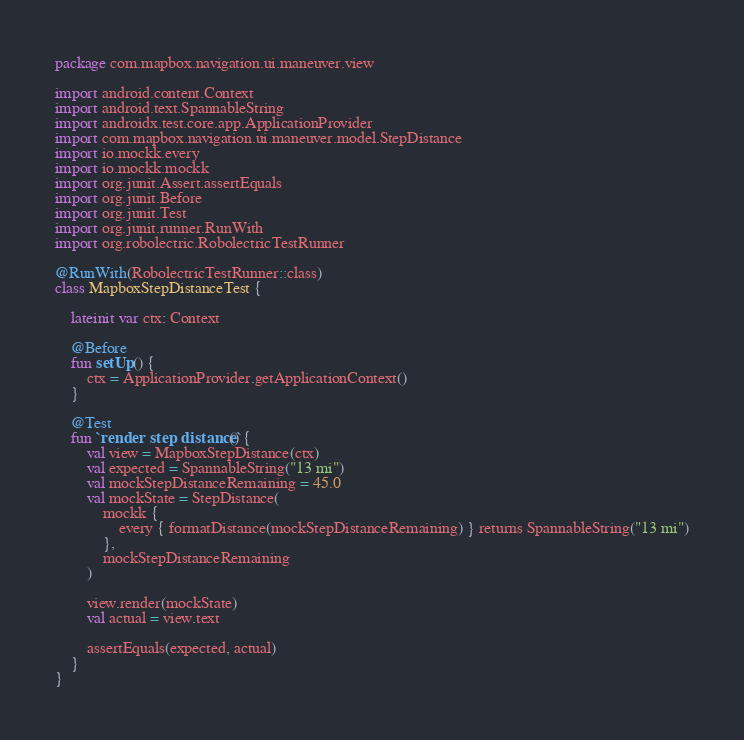Convert code to text. <code><loc_0><loc_0><loc_500><loc_500><_Kotlin_>package com.mapbox.navigation.ui.maneuver.view

import android.content.Context
import android.text.SpannableString
import androidx.test.core.app.ApplicationProvider
import com.mapbox.navigation.ui.maneuver.model.StepDistance
import io.mockk.every
import io.mockk.mockk
import org.junit.Assert.assertEquals
import org.junit.Before
import org.junit.Test
import org.junit.runner.RunWith
import org.robolectric.RobolectricTestRunner

@RunWith(RobolectricTestRunner::class)
class MapboxStepDistanceTest {

    lateinit var ctx: Context

    @Before
    fun setUp() {
        ctx = ApplicationProvider.getApplicationContext()
    }

    @Test
    fun `render step distance`() {
        val view = MapboxStepDistance(ctx)
        val expected = SpannableString("13 mi")
        val mockStepDistanceRemaining = 45.0
        val mockState = StepDistance(
            mockk {
                every { formatDistance(mockStepDistanceRemaining) } returns SpannableString("13 mi")
            },
            mockStepDistanceRemaining
        )

        view.render(mockState)
        val actual = view.text

        assertEquals(expected, actual)
    }
}
</code> 